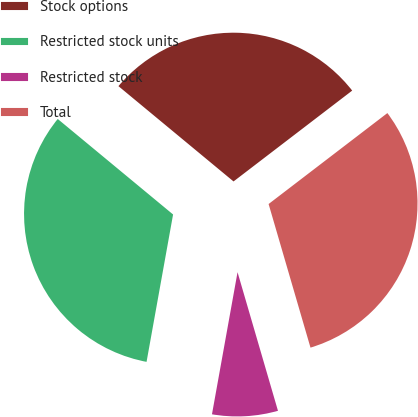Convert chart to OTSL. <chart><loc_0><loc_0><loc_500><loc_500><pie_chart><fcel>Stock options<fcel>Restricted stock units<fcel>Restricted stock<fcel>Total<nl><fcel>28.59%<fcel>33.17%<fcel>7.35%<fcel>30.88%<nl></chart> 